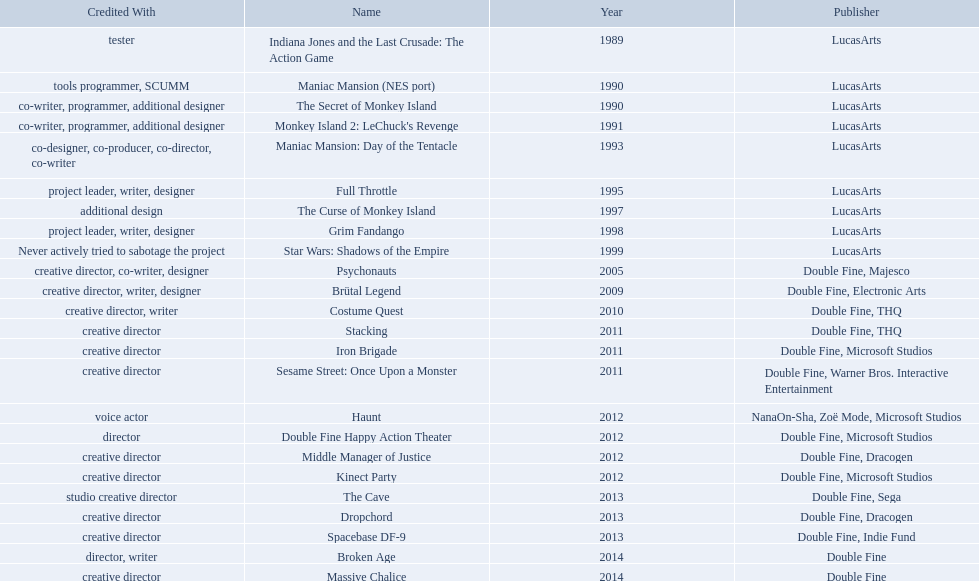Which game is credited with a creative director? Creative director, co-writer, designer, creative director, writer, designer, creative director, writer, creative director, creative director, creative director, creative director, creative director, creative director, creative director, creative director. Of these games, which also has warner bros. interactive listed as creative director? Sesame Street: Once Upon a Monster. 